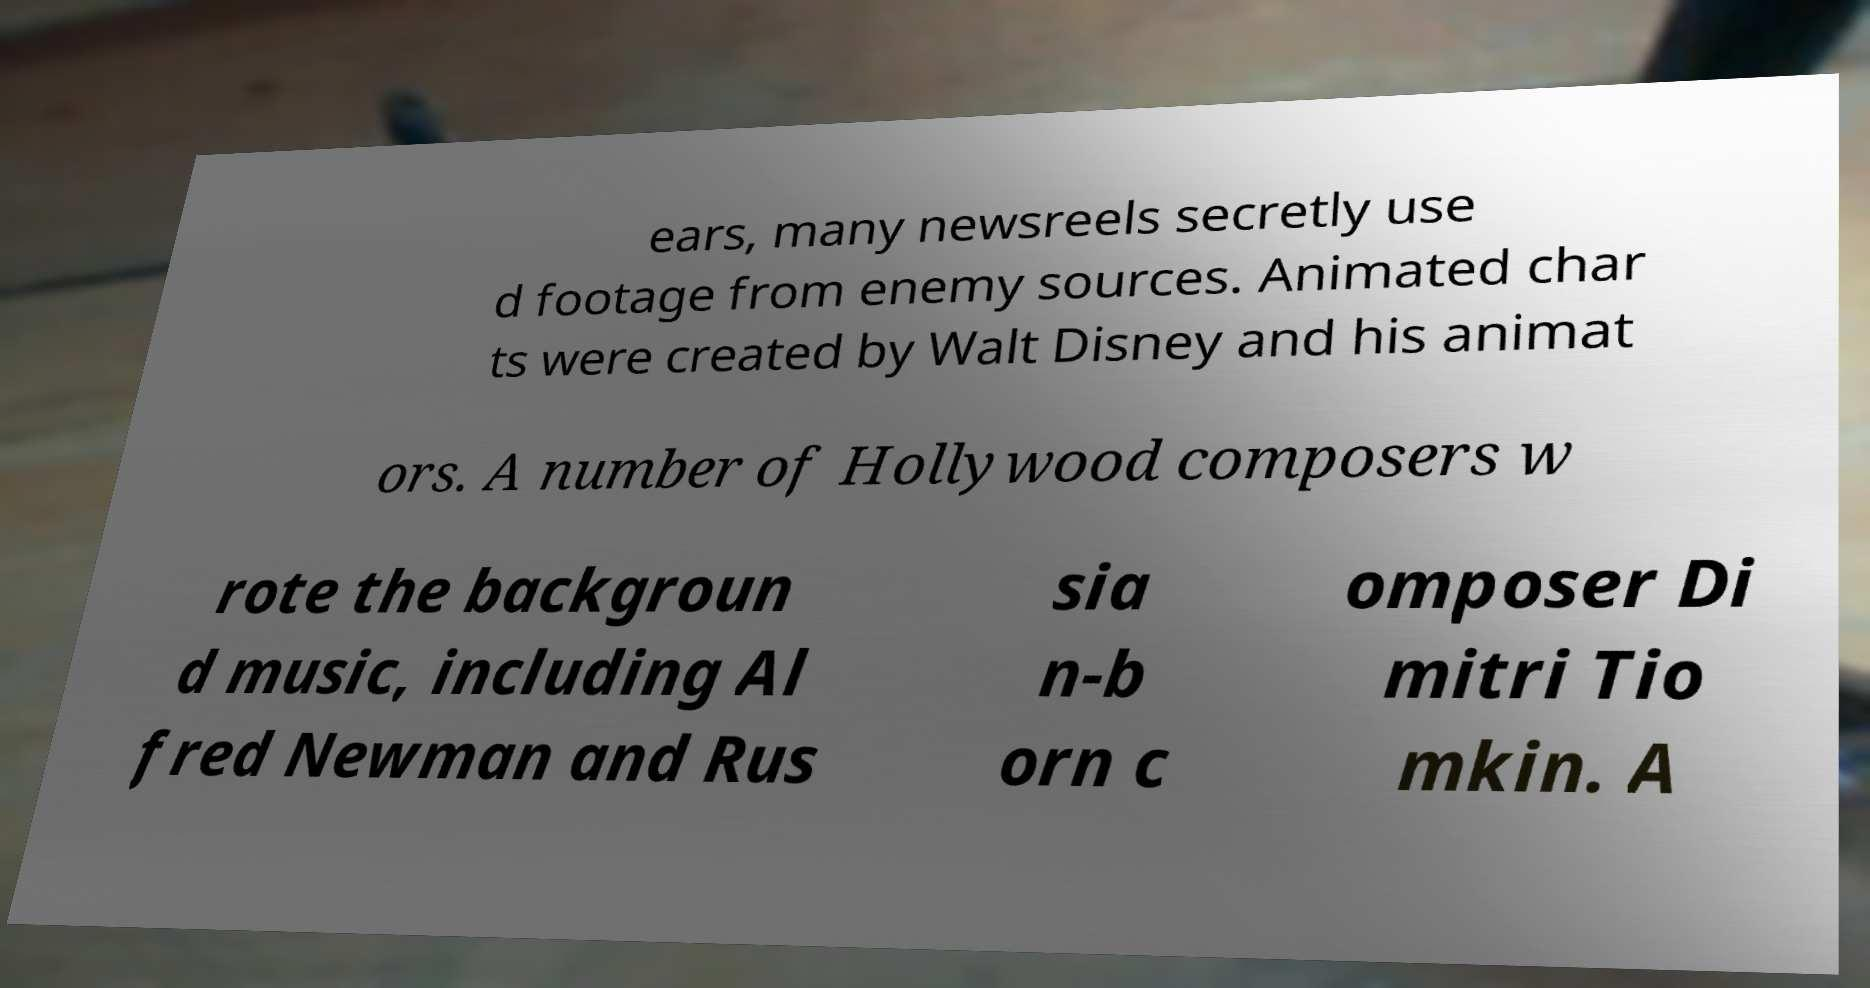Could you extract and type out the text from this image? ears, many newsreels secretly use d footage from enemy sources. Animated char ts were created by Walt Disney and his animat ors. A number of Hollywood composers w rote the backgroun d music, including Al fred Newman and Rus sia n-b orn c omposer Di mitri Tio mkin. A 